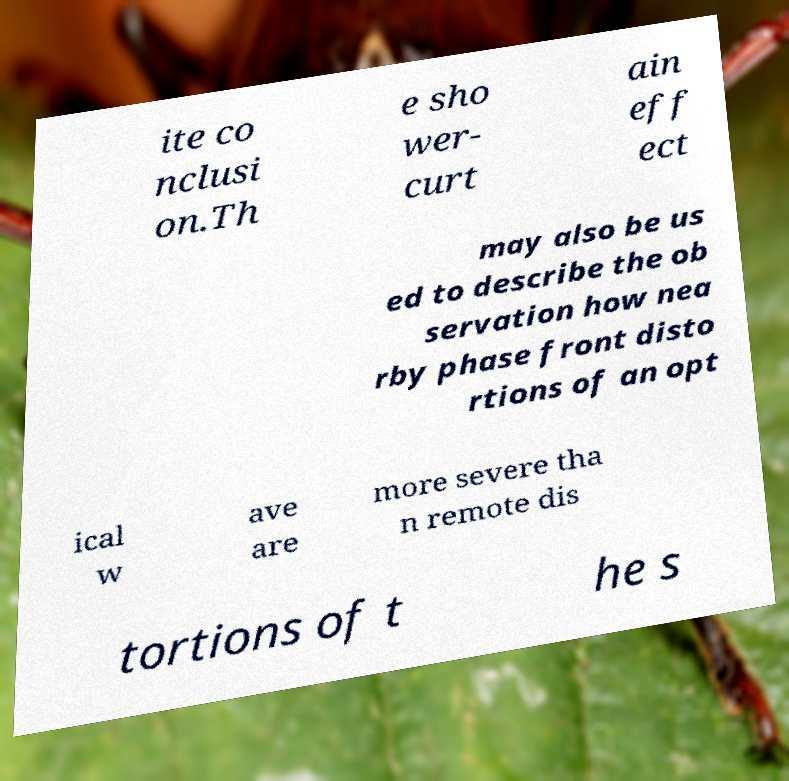Could you extract and type out the text from this image? ite co nclusi on.Th e sho wer- curt ain eff ect may also be us ed to describe the ob servation how nea rby phase front disto rtions of an opt ical w ave are more severe tha n remote dis tortions of t he s 